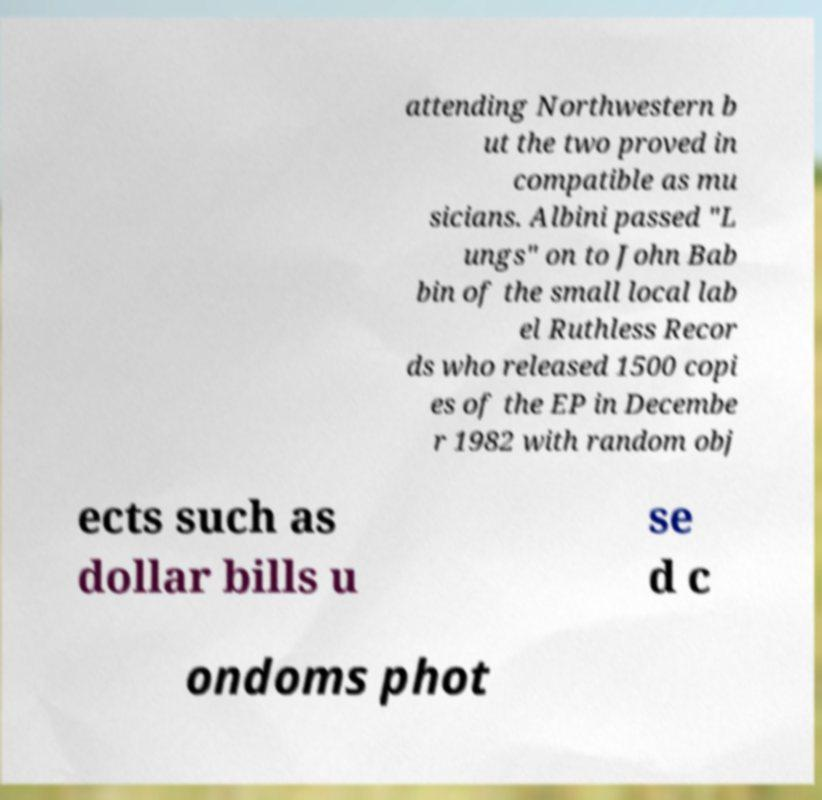I need the written content from this picture converted into text. Can you do that? attending Northwestern b ut the two proved in compatible as mu sicians. Albini passed "L ungs" on to John Bab bin of the small local lab el Ruthless Recor ds who released 1500 copi es of the EP in Decembe r 1982 with random obj ects such as dollar bills u se d c ondoms phot 